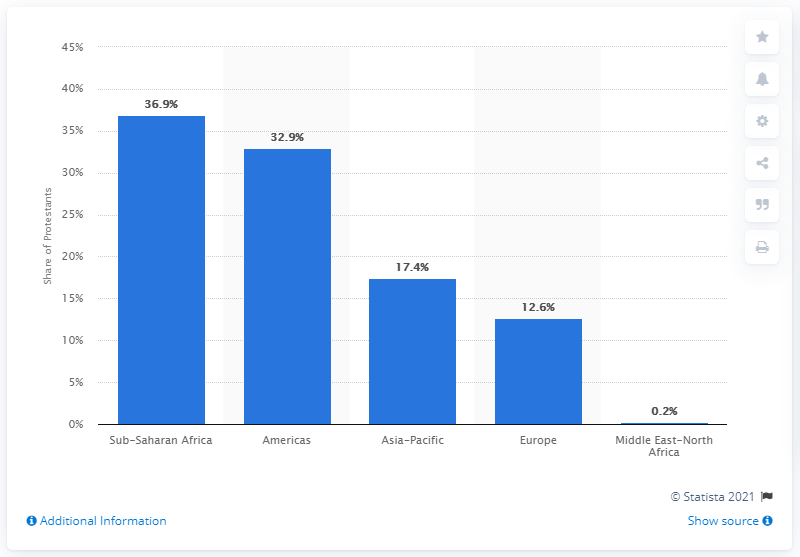Give some essential details in this illustration. In 2010, approximately 12.6% of all Protestants worldwide lived in Europe, according to recent estimates. 